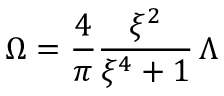Convert formula to latex. <formula><loc_0><loc_0><loc_500><loc_500>\Omega = \frac { 4 } { \pi } \frac { \xi ^ { 2 } } { \xi ^ { 4 } + 1 } \, \Lambda</formula> 